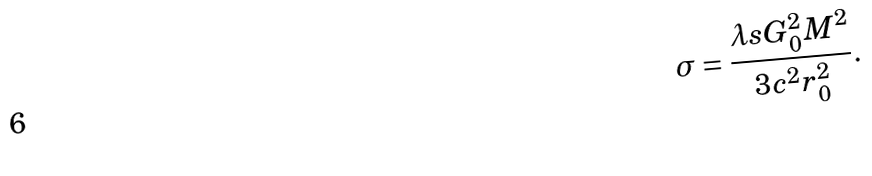Convert formula to latex. <formula><loc_0><loc_0><loc_500><loc_500>\sigma = \frac { \lambda s G _ { 0 } ^ { 2 } M ^ { 2 } } { 3 c ^ { 2 } r _ { 0 } ^ { 2 } } .</formula> 